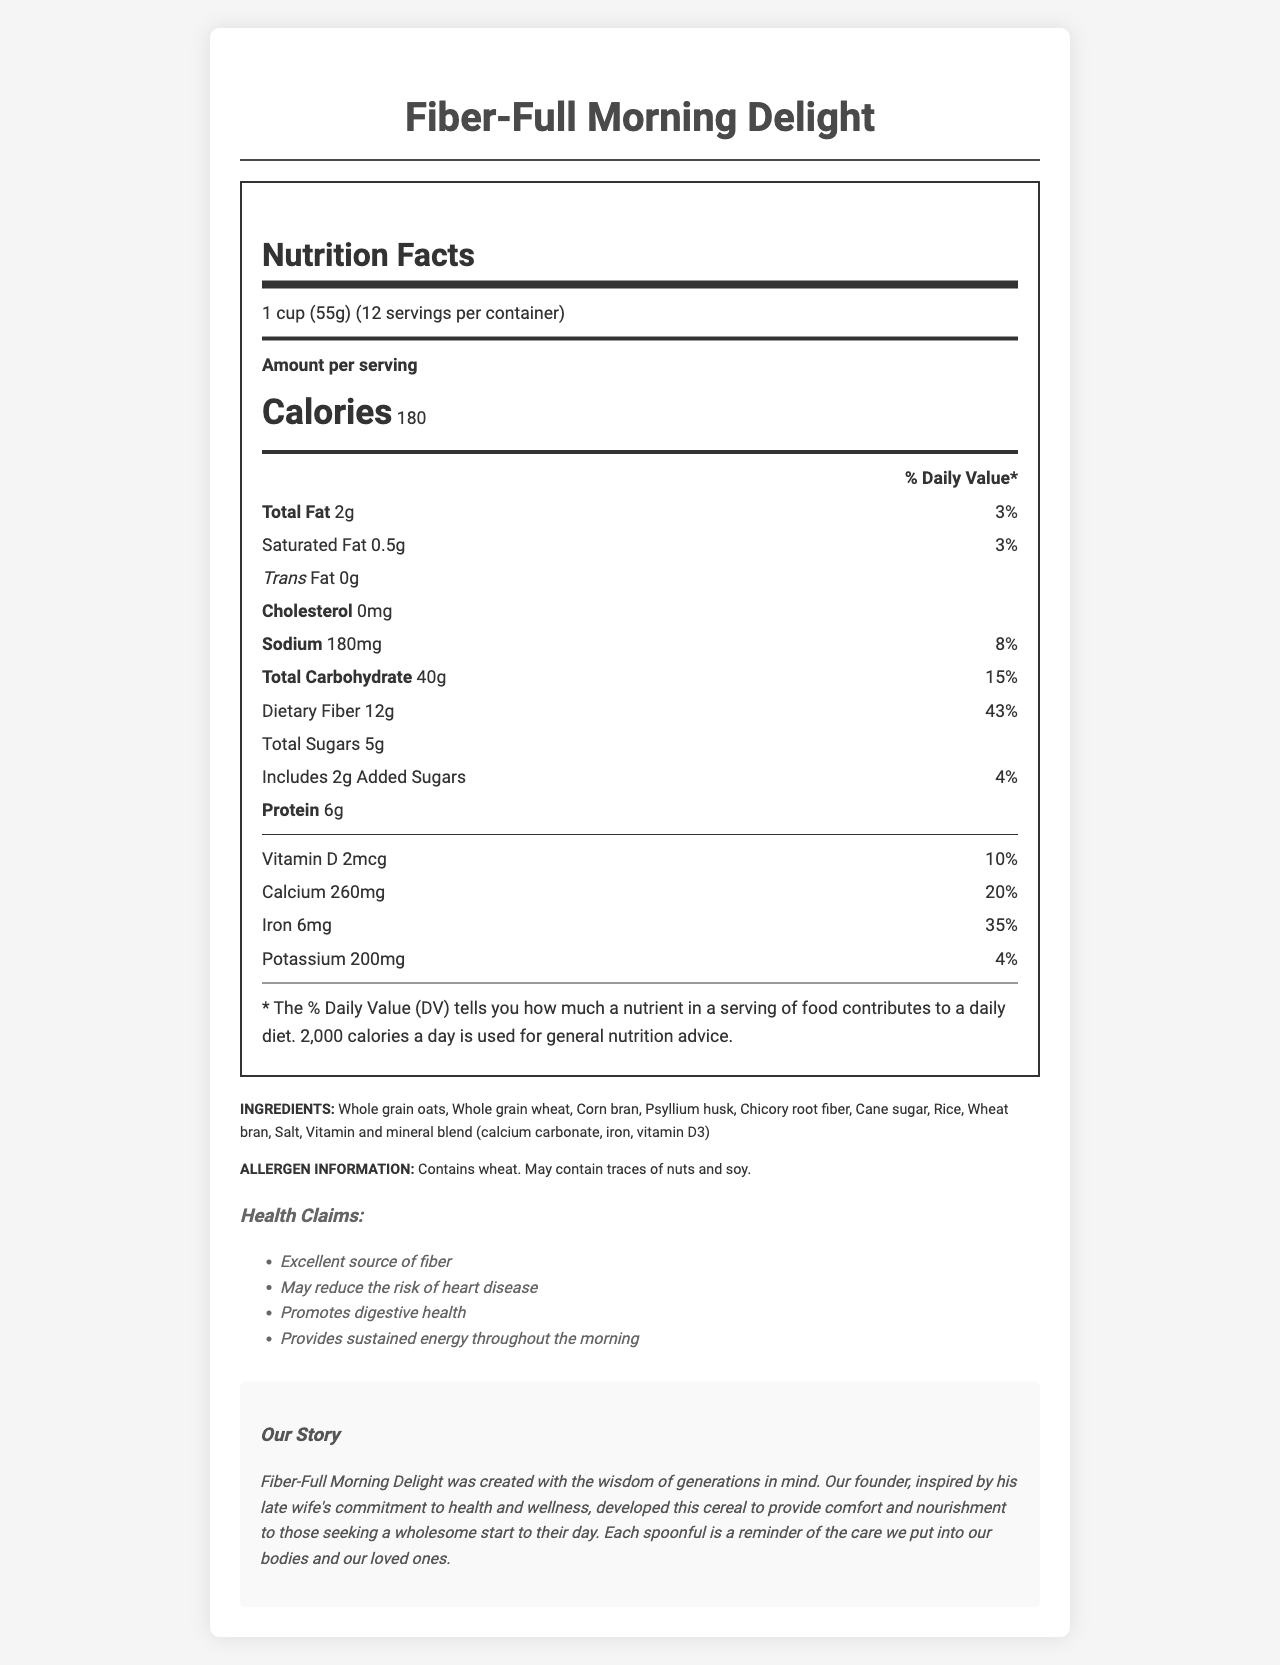what is the serving size? The serving size is listed at the beginning of the nutrition facts section.
Answer: 1 cup (55g) how many calories are in one serving of Fiber-Full Morning Delight? The number of calories per serving is prominently displayed after the serving size section in the nutrition facts label.
Answer: 180 what is the amount of total fat per serving? The total fat amount is listed under the nutrition facts, with a percent daily value of 3%.
Answer: 2g what is the percentage of the daily value of dietary fiber per serving? This information is provided under the "Total Carbohydrate" section in the nutrition facts, specifying both the amount (12g) and the percent daily value (43%).
Answer: 43% what vitamins and minerals are included in Fiber-Full Morning Delight? The vitamins and minerals are listed under the nutrition facts, particularly after the protein information.
Answer: Vitamin D, Calcium, Iron, Potassium Choose the correct amount of sodium per serving: A. 150mg B. 180mg C. 200mg The sodium content per serving is 180mg, as mentioned in the nutrition facts.
Answer: B What is the added sugars percentage of the daily value? A. 3% B. 4% C. 5% D. 6% The added sugars amount (2g) and its percent daily value (4%) are mentioned under the "Total Sugars" section in the nutrition facts.
Answer: B Does Fiber-Full Morning Delight contain any cholesterol? The nutrition facts list cholesterol as 0mg, indicating that the product contains no cholesterol.
Answer: No describe the main idea of the document This summary encompasses all the key sections of the document, providing an overview of its contents and the cereal’s overall value proposition.
Answer: The document provides detailed nutritional information for Fiber-Full Morning Delight, a high-fiber breakfast cereal. It highlights the serving size, calorie content, and various nutrients along with their amounts and daily values. It also includes ingredients, allergen information, health claims, storage instructions, serving suggestions, and a touching brand story that emphasizes the founder’s dedication to health and wellness inspired by his late wife. how many servings are there in a container? The number of servings per container is listed at the top of the nutrition facts section.
Answer: 12 which ingredient is not listed in the ingredients section: A. Psyllium husk B. High fructose corn syrup C. Rice D. Salt High fructose corn syrup is not listed among the ingredients, while the other options are.
Answer: B is this product an excellent source of fiber? One of the health claims listed in the document states that the product is an "Excellent source of fiber."
Answer: Yes where should the product be stored? The storage instructions specify that the product should be stored in a cool, dry place and that the package should be closed tightly after opening.
Answer: In a cool, dry place; close package tightly after opening to maintain freshness what was the inspiration behind the creation of Fiber-Full Morning Delight? The brand story mentions that the founder was inspired by his late wife’s dedication to health and wellness in developing this product.
Answer: The founder's late wife’s commitment to health and wellness what is the primary benefit that the health claims emphasize? The health claims section emphasizes that the product promotes digestive health and provides sustained energy throughout the morning.
Answer: Promoting digestive health and providing sustained energy what is the country of origin of this product? The document does not provide information regarding the country of origin of the product.
Answer: Cannot be determined 